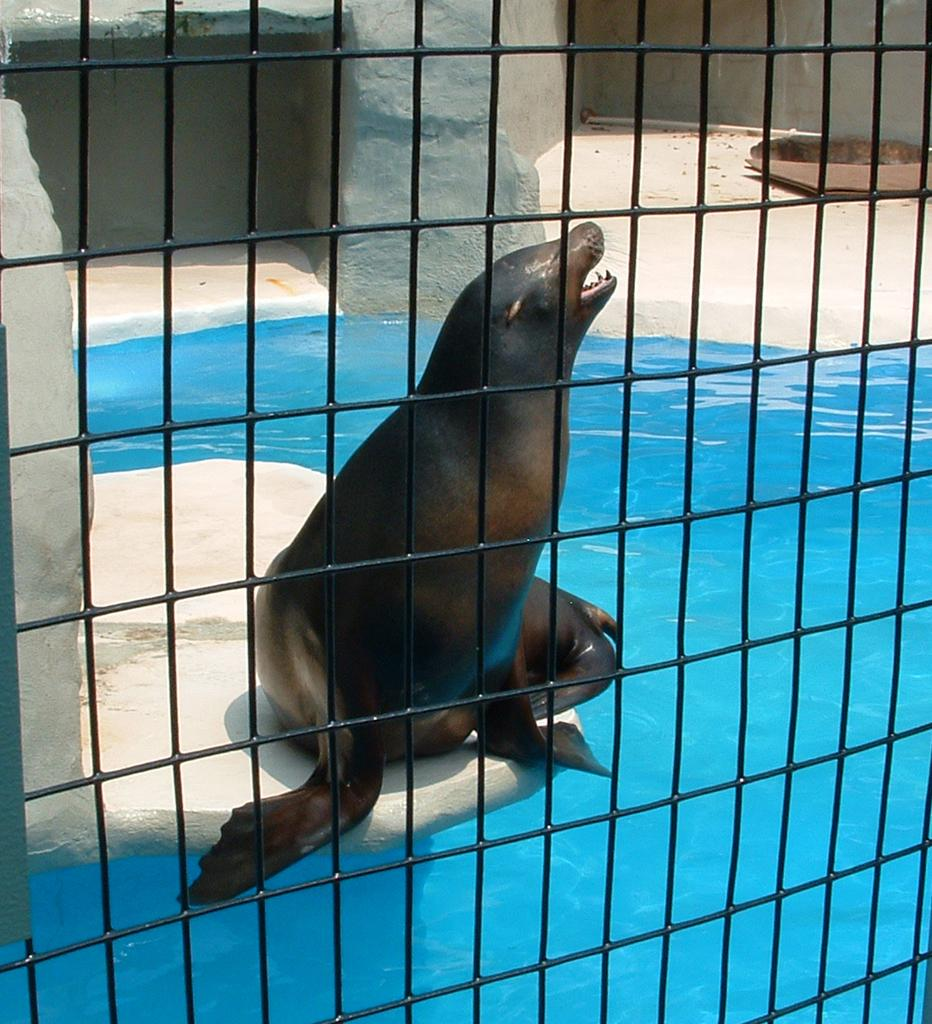What animal can be seen in the image? There is a sea lion on a stone in the image. What type of water feature is present in the image? There is a swimming pool in the image. What architectural element is visible in the background of the image? There is a wall partition in the background of the image. What type of barrier is present in the front of the image? There is steel fencing in the front of the image. How many eggs are being used in the school depicted in the image? There is no school or eggs present in the image. How many men are visible in the image? There are no men present in the image. 